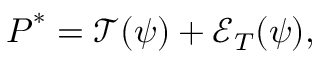<formula> <loc_0><loc_0><loc_500><loc_500>P ^ { * } = \mathcal { T } ( \psi ) + \mathcal { E } _ { T } ( \psi ) ,</formula> 